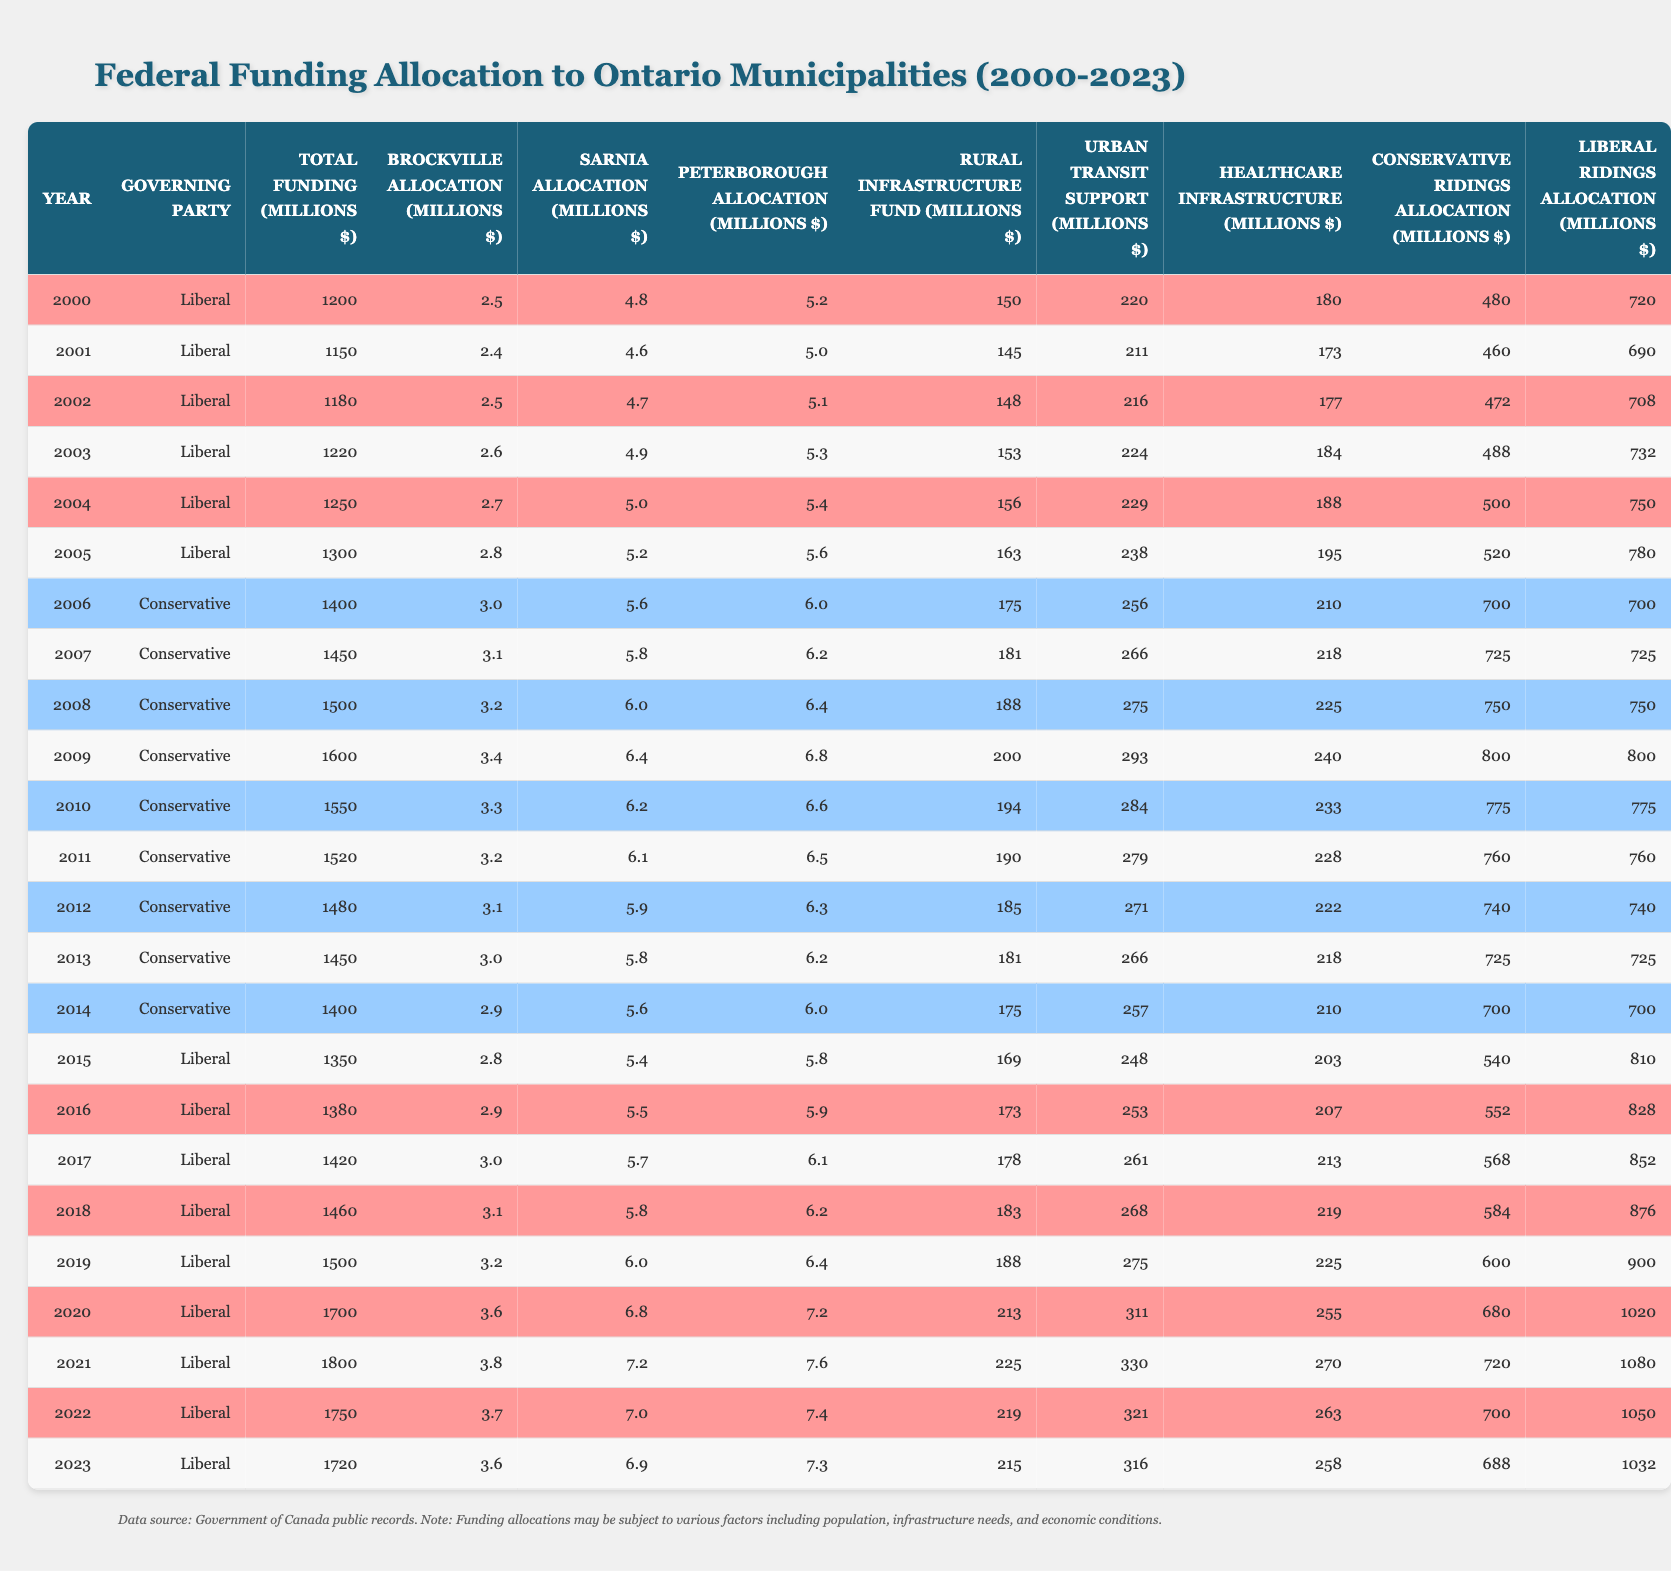What was the total federal funding allocated to Ontario municipalities in 2020? To answer this, we look at the row for the year 2020 in the table, which indicates that the total funding was 1700 million dollars.
Answer: 1700 million Which party was in power in 2015? The governing party for the year 2015, as seen in the table, was the Liberal Party.
Answer: Liberal What was the allocation for Brockville in 2010? Checking the row for 2010 reveals that Brockville's allocation was 3.3 million dollars.
Answer: 3.3 million Which year saw the highest allocation to Conservative ridings? Looking through the Conservative ridings allocation, the highest value is noted in 2021, which showed an allocation of 680 million dollars.
Answer: 2021 What is the difference in total funding between 2000 and 2023? The funding in 2000 was 1200 million dollars and in 2023 was 1720 million dollars. The difference is calculated as 1720 - 1200 = 520 million dollars.
Answer: 520 million In which year did the Rural Infrastructure Fund allocation exceed 200 million dollars? By checking the Rural Infrastructure Fund allocations, we observe that it first exceeded 200 million dollars in the year 2009, where the allocation was 200 million dollars.
Answer: 2009 What percentage of total funding was allocated to Urban Transit Support in 2007? The total funding for 2007 was 1450 million dollars, and for Urban Transit Support, it was 266 million dollars. To get the percentage, we calculate (266 / 1450) * 100 = 18.4%.
Answer: 18.4% How much funding was allocated to Sarnia in 2004 compared to its allocation in 2020? In 2004, Sarnia received 5 million dollars, while in 2020 it received 6.8 million dollars. The difference between the two allocations is 6.8 - 5 = 1.8 million dollars more in 2020.
Answer: 1.8 million Did Liberal ridings consistently receive more funding than Conservative ridings from 2000 to 2023? By comparing the allocation values year by year in the table, it's evident that Liberal ridings had higher funding in the majority of years, although there are instances when Conservative ridings received more. Hence, the statement is not entirely true.
Answer: No What was the total allocation to healthcare infrastructure in 2022? Referring to the healthcare infrastructure column for the year 2022, the total allocation is noted to be 263 million dollars.
Answer: 263 million 